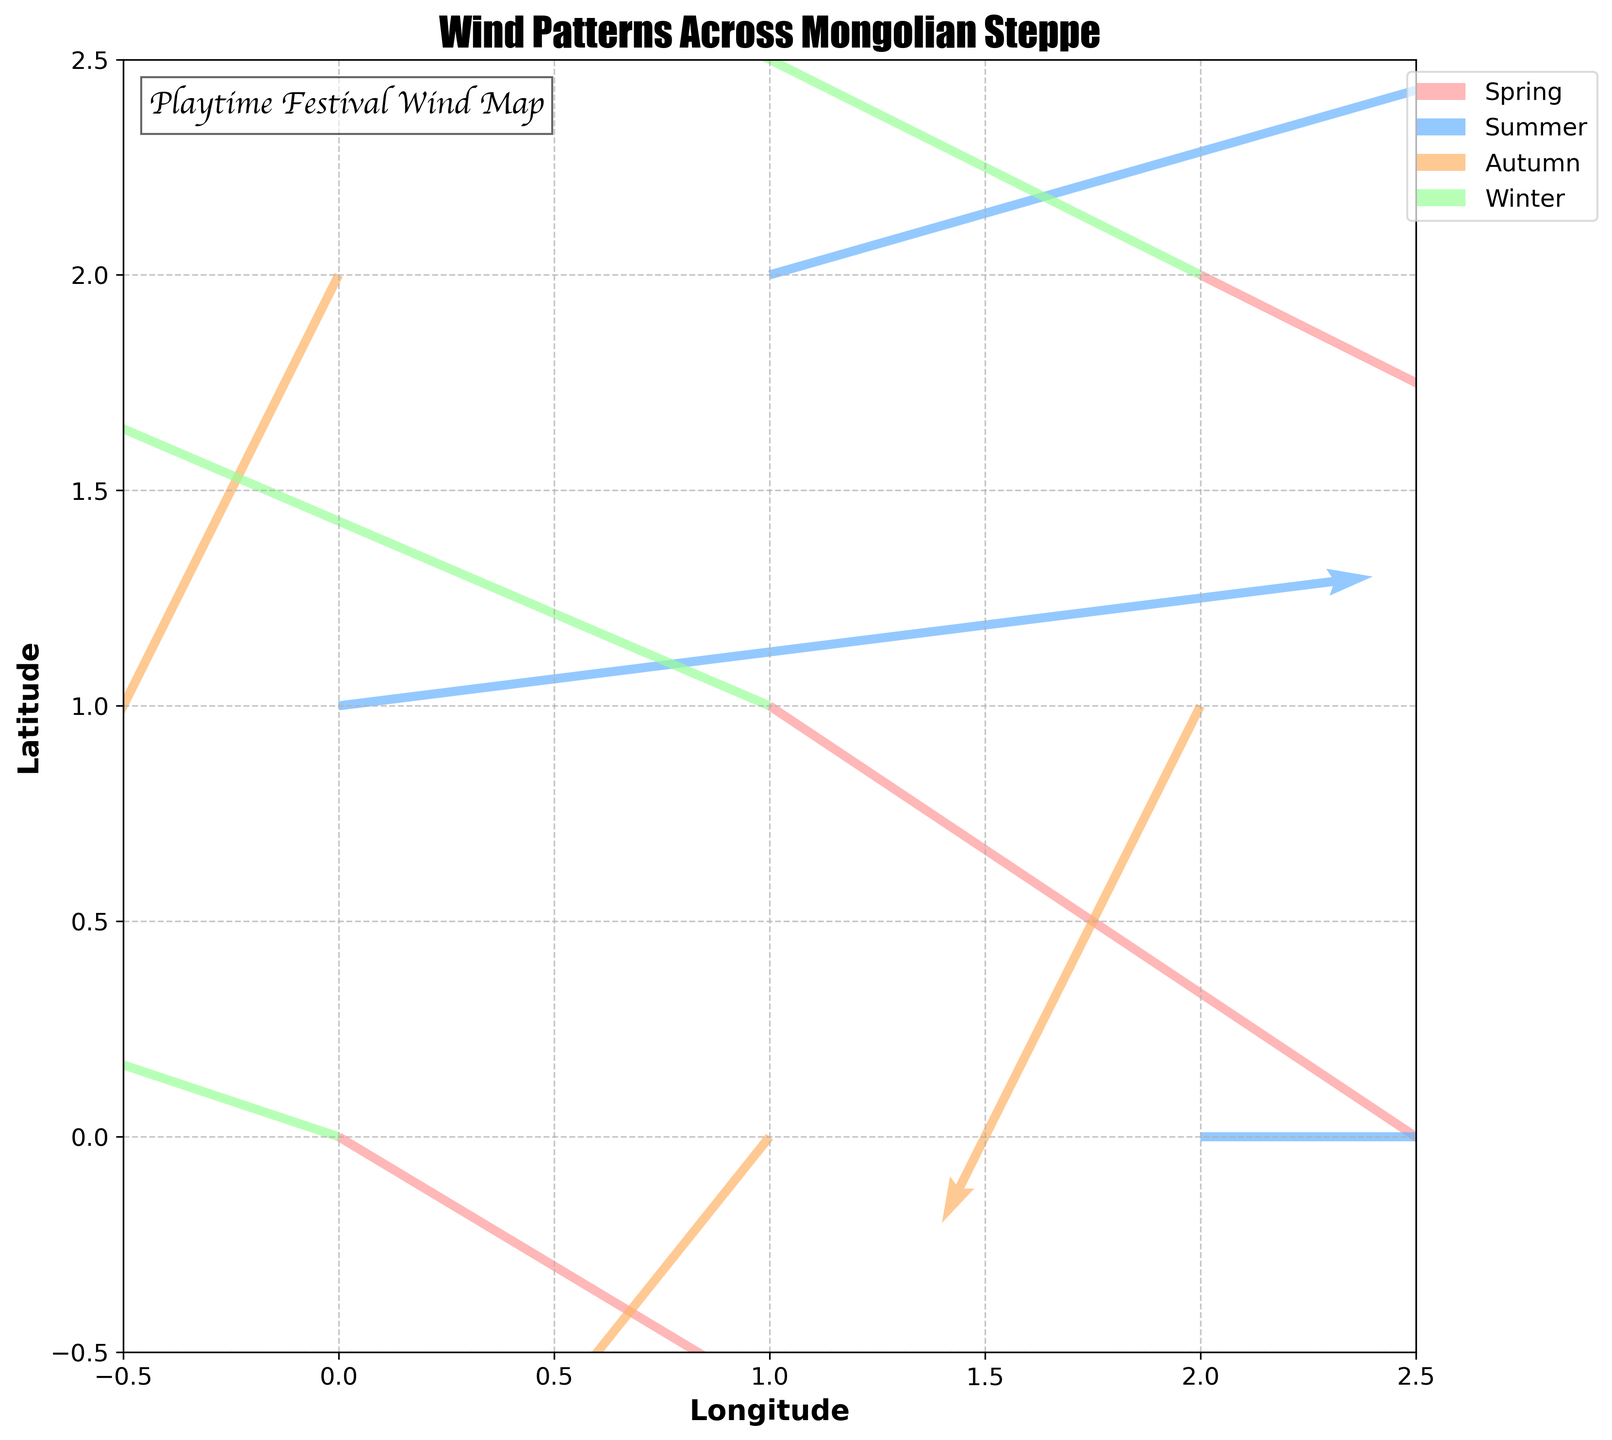What is the title of the figure? The title can be seen at the top of the figure. It reads "Wind Patterns Across Mongolian Steppe".
Answer: Wind Patterns Across Mongolian Steppe What does the green color represent? The legend on the right side of the figure labels the seasons with their corresponding colors. Green corresponds to "Winter".
Answer: Winter Which season shows the most significant wind intensity at the coordinate (0,2)? By looking at the arrows starting at (0,2), we see a large arrow in the green color that corresponds to Winter with vectors (-1.5, -3.0). The figure shows the intensity and direction of the wind in Winter at this coordinate.
Answer: Winter What seasons have data points at coordinate (1,1)? By observing the figure, the arrows start at coordinate (1,1) in the colors red and dark blue corresponding to Spring and Winter respectively.
Answer: Spring and Winter Which season has the highest wind speed magnitude at coordinate (1,1)? The magnitudes of the wind vectors are calculated by sqrt(u^2 + v^2). For Spring, the vector is (3.0, -2.0) with magnitude sqrt(3.0^2 + (-2.0)^2) = sqrt(9 + 4) = 3.61. For Winter, it is (-3.5, 1.5) with magnitude sqrt((-3.5)^2 + 1.5^2) = sqrt(12.25 + 2.25) = 3.80. Thus, Winter has a higher magnitude.
Answer: Winter How many data points are displayed for each season? There are four groups of vectors, each color-coded. Counting the vectors per color: Spring has 3, Summer has 3, Autumn has 3, and Winter has 3.
Answer: 3 data points per season Which season has a wind arrow pointing towards the east at coordinate (0,1)? Observing the wind arrows starting at (0,1) and looking for an arrow pointing towards the east direction (right), we see a yellow arrow for Summer with a vector (4.0, 0.5).
Answer: Summer What's the general wind direction trend in Autumn? Observing the arrows in the brown color for Autumn, we see all arrows generally pointing towards a southwest direction, which are vectors (-1.5, -3.0), (-2.0, -2.5), and (-1.0, -2.0).
Answer: Southwest Which season does not have any data points at coordinate (2,0)? Checking the arrows starting at (2,0), there is only one arrow in yellow for Summer. No other season has an arrow starting at this point.
Answer: Spring, Autumn, Winter In which season is the wind at (2,2) moving towards the northeast direction? By looking at the arrows starting at (2,2), the wind vector for Winter is (-4.0, 2.0), which is directed towards the northeast.
Answer: Winter 